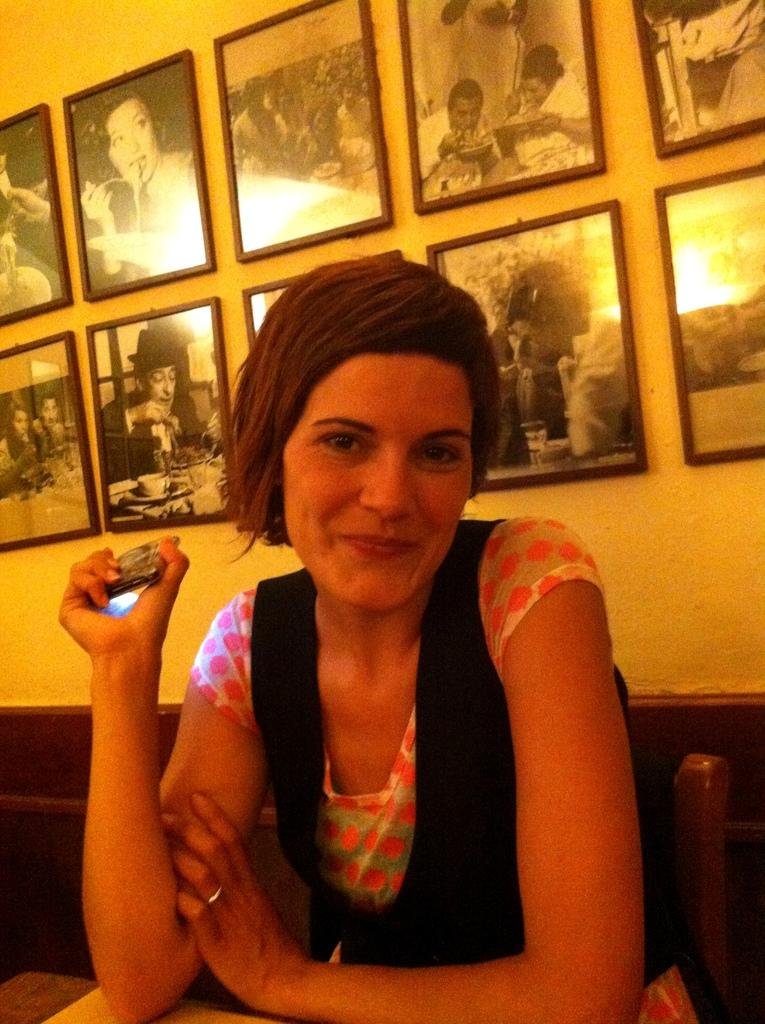What can be seen in the image? There is a person in the image. What is the person doing in the image? The person is holding an object. What is visible in the background of the image? There is a wall visible in the image. What is on the wall in the image? There is a group of photo frames on the wall. What can be seen in the photo frames? The photo frames contain images of persons. What type of bottle is being used by the person on the stage in the image? There is no stage or bottle present in the image. Can you describe the toad that is sitting on the person's shoulder in the image? There is no toad present in the image. 